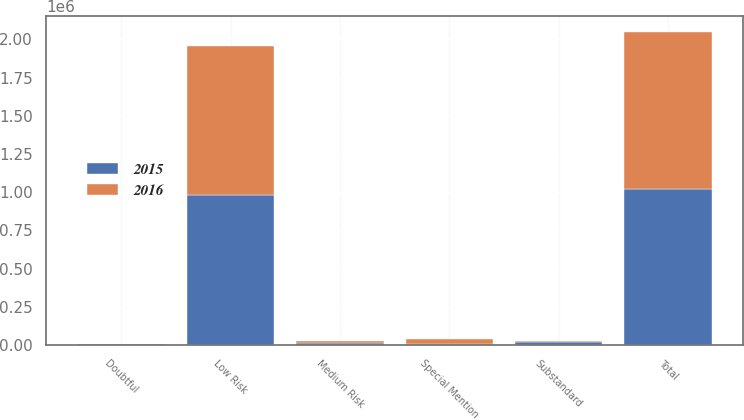<chart> <loc_0><loc_0><loc_500><loc_500><stacked_bar_chart><ecel><fcel>Doubtful<fcel>Substandard<fcel>Special Mention<fcel>Medium Risk<fcel>Low Risk<fcel>Total<nl><fcel>2016<fcel>1333<fcel>1773<fcel>30152<fcel>14620<fcel>978712<fcel>1.02659e+06<nl><fcel>2015<fcel>5169<fcel>21774<fcel>6271<fcel>11494<fcel>979152<fcel>1.02386e+06<nl></chart> 